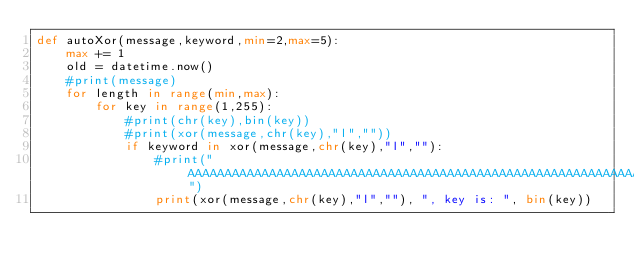<code> <loc_0><loc_0><loc_500><loc_500><_Python_>def autoXor(message,keyword,min=2,max=5):
    max += 1
    old = datetime.now()
    #print(message)
    for length in range(min,max):
        for key in range(1,255):    
            #print(chr(key),bin(key))
            #print(xor(message,chr(key),"l",""))
            if keyword in xor(message,chr(key),"l",""):
                #print("AAAAAAAAAAAAAAAAAAAAAAAAAAAAAAAAAAAAAAAAAAAAAAAAAAAAAAAAAAAAAAAAAAAAA")
                print(xor(message,chr(key),"l",""), ", key is: ", bin(key))</code> 